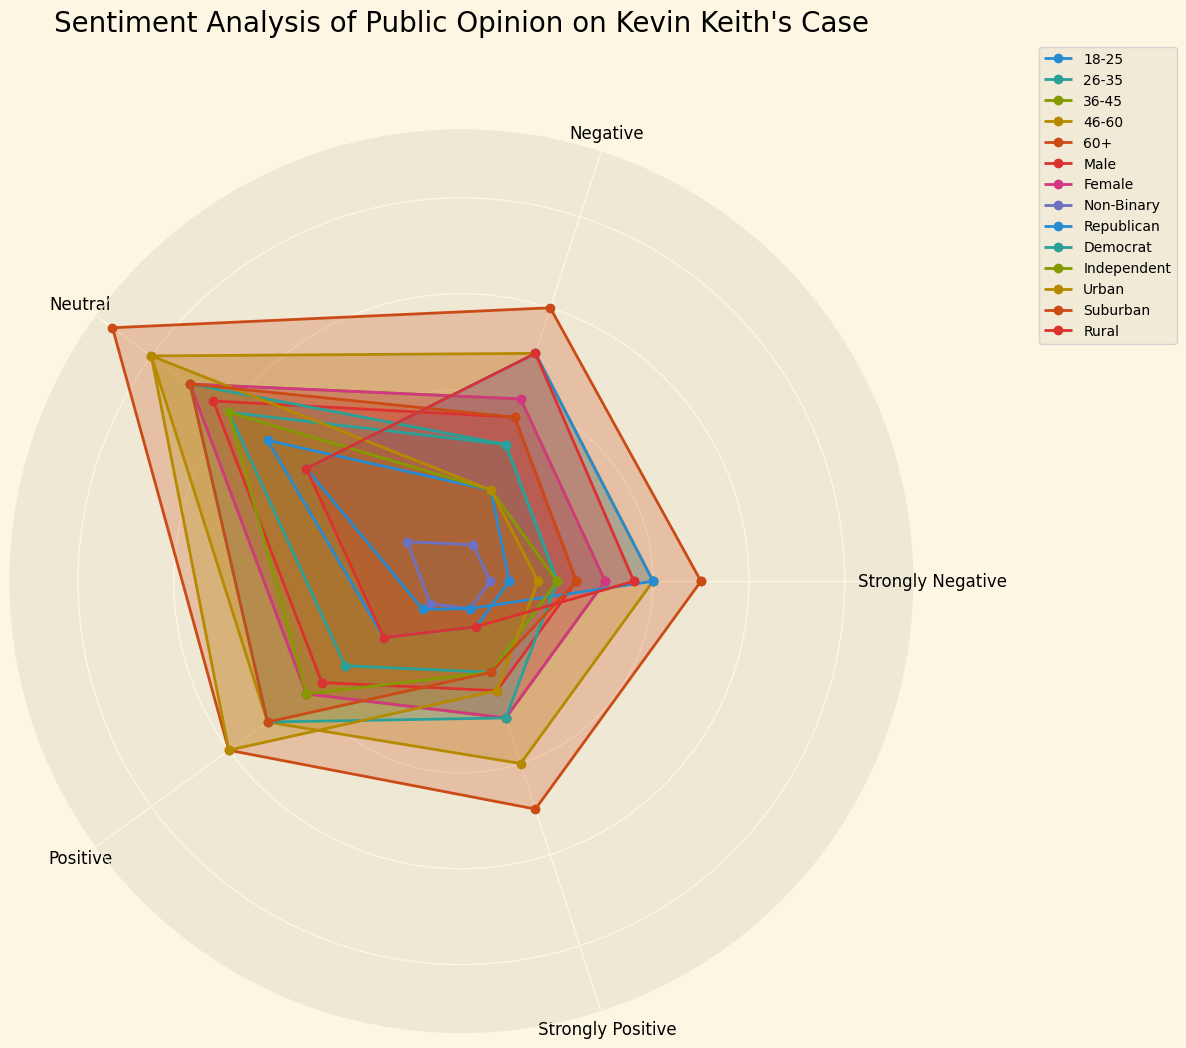What's the average positive sentiment among all age groups? Calculate the positive sentiment for each age group and find the average. For 18-25 (10), 26-35 (15), 36-45 (20), 46-60 (25), and 60+ (30), sum = 10 + 15 + 20 + 25 + 30 = 100. Average = 100/5 = 20
Answer: 20 Which demographic has the highest percentage of strongly negative sentiment? Identify the highest value in the "Strongly Negative" column. The values are 5, 10, 15, 20, and 25 for different age groups, and 12, 15, 3, 20, 10, 10, 8, 12, 18, with "60+" having the highest at 25
Answer: 60+ Are males generally more positive or negative about the case compared to females? Compare the sum of positive (18+12=30) and negative (12+18=30) sentiments for males with that of females (20+15=35 positive and 15+20=35 negative). Both genders have equal negative sentiment, but females have slightly higher positive sentiment
Answer: Females are slightly more positive Which of the political affiliations shows the most neutral sentiment? Check the values in the "Neutral" column. Republicans (20), Democrats (35), Independents (30). Democrats have the highest value at 35
Answer: Democrats Is there a group with a close to equal distribution among all sentiment categories? Look for groups where values in all sentiment categories are similar. For Non-Binary, values are 3, 4, 7, 4, 3 which are relatively balanced across categories
Answer: Non-Binary Compare the overall positive sentiment for urban, suburban, and rural areas. Which is the highest? Compare the "Positive" values: Urban (30), Suburban (25), Rural (10). Urban has the highest positive sentiment
Answer: Urban What's the combined strongly positive sentiment for those aged 46-60 and 60+? Add the "Strongly Positive" values for 46-60 (20) and 60+ (25). Combined = 20 + 25 = 45
Answer: 45 Which demographic has the closest balance between negative and positive sentiments? Look at the difference between "Negative" and "Positive" values for each group. Males have 18 negative and 18 positive, showing the closest balance
Answer: Males How does the sentiment of 36-45 age group compare to 60+ in terms of neutrality? Compare the "Neutral" sentiment: 36-45 (35) and 60+ (45). The 60+ group has a higher neutral sentiment
Answer: 60+ Is there any demographic where the negative sentiment outweighs the positive sentiment significantly? Compare "Negative" and "Positive" values. Republicans have a substantial difference with 25 Negative and 5 Positive
Answer: Republicans 